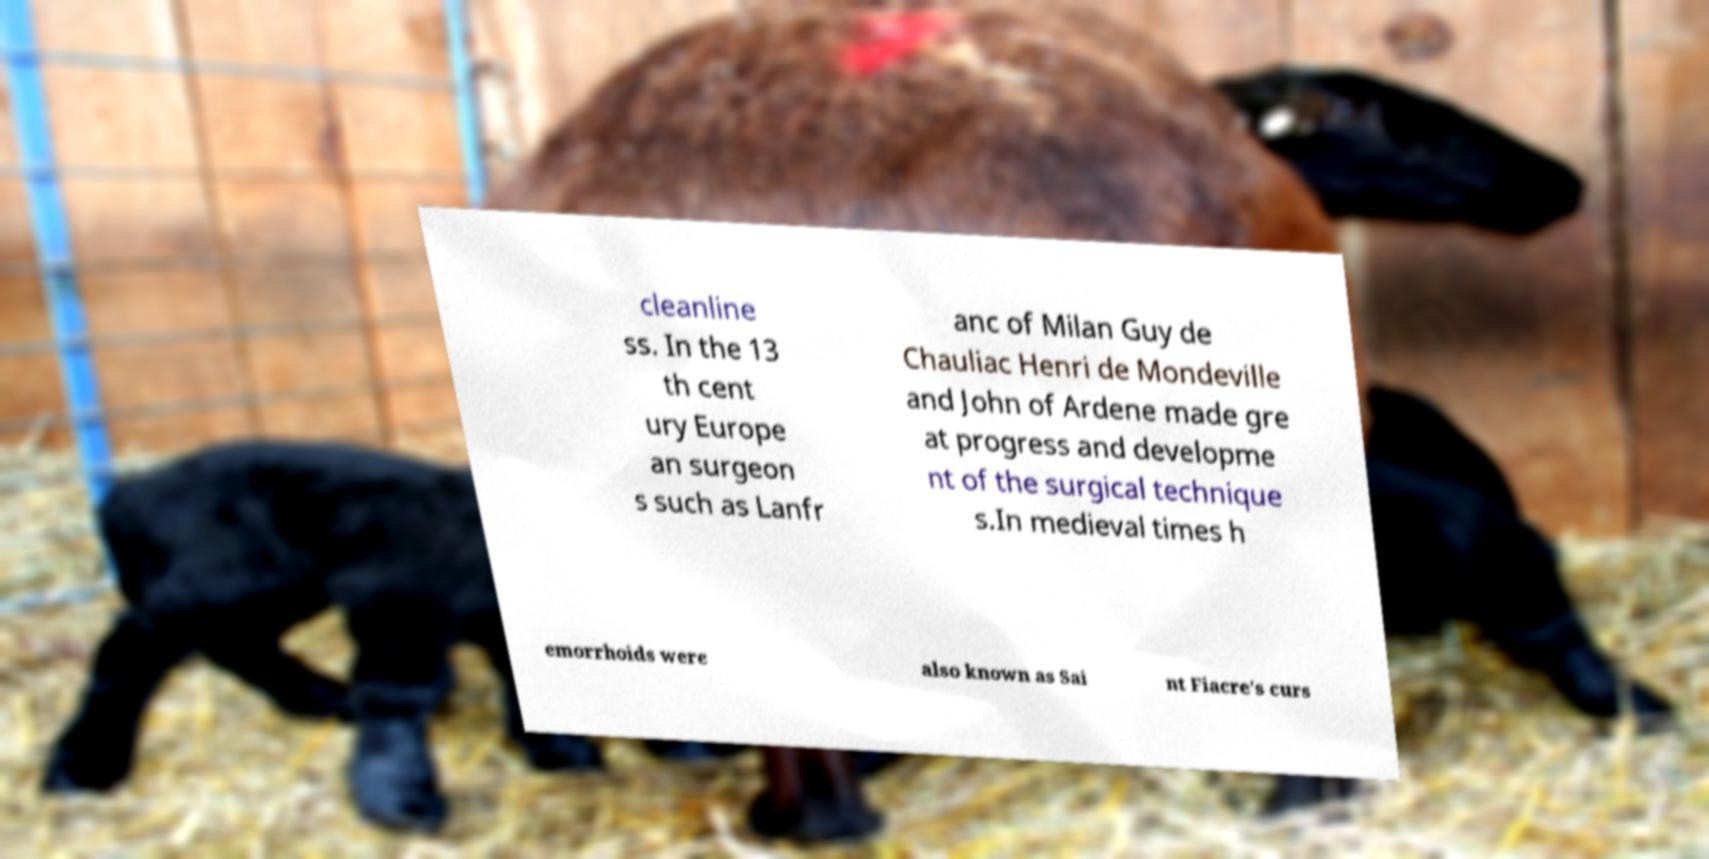For documentation purposes, I need the text within this image transcribed. Could you provide that? cleanline ss. In the 13 th cent ury Europe an surgeon s such as Lanfr anc of Milan Guy de Chauliac Henri de Mondeville and John of Ardene made gre at progress and developme nt of the surgical technique s.In medieval times h emorrhoids were also known as Sai nt Fiacre's curs 